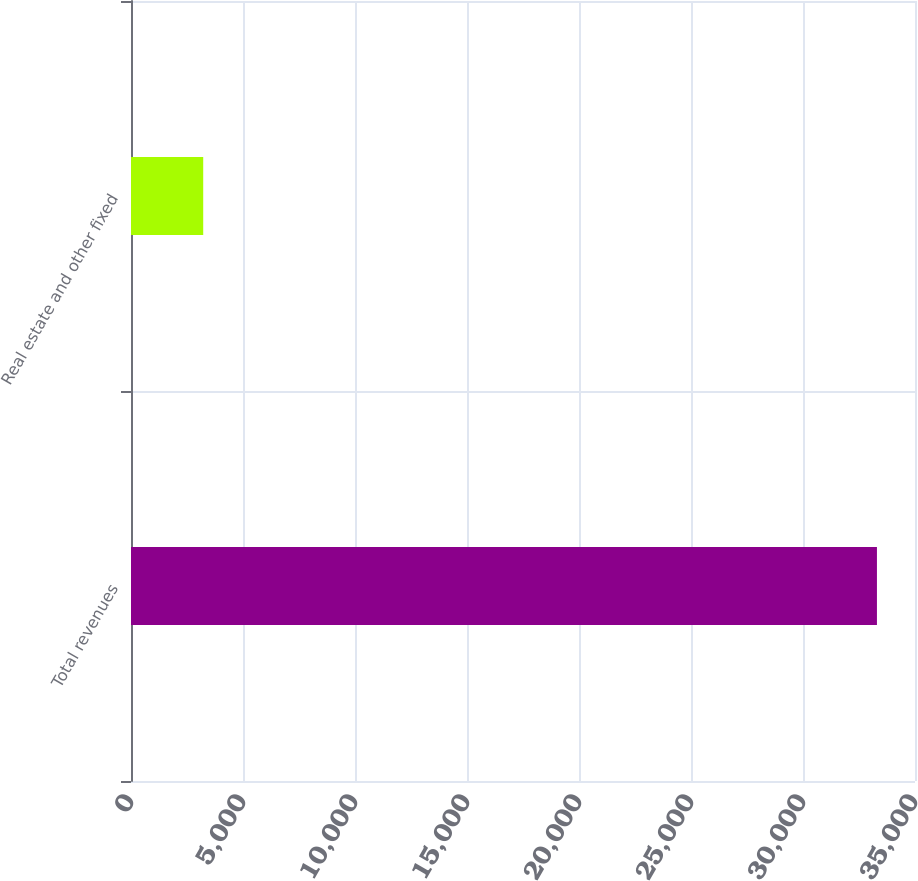Convert chart to OTSL. <chart><loc_0><loc_0><loc_500><loc_500><bar_chart><fcel>Total revenues<fcel>Real estate and other fixed<nl><fcel>33301<fcel>3224<nl></chart> 